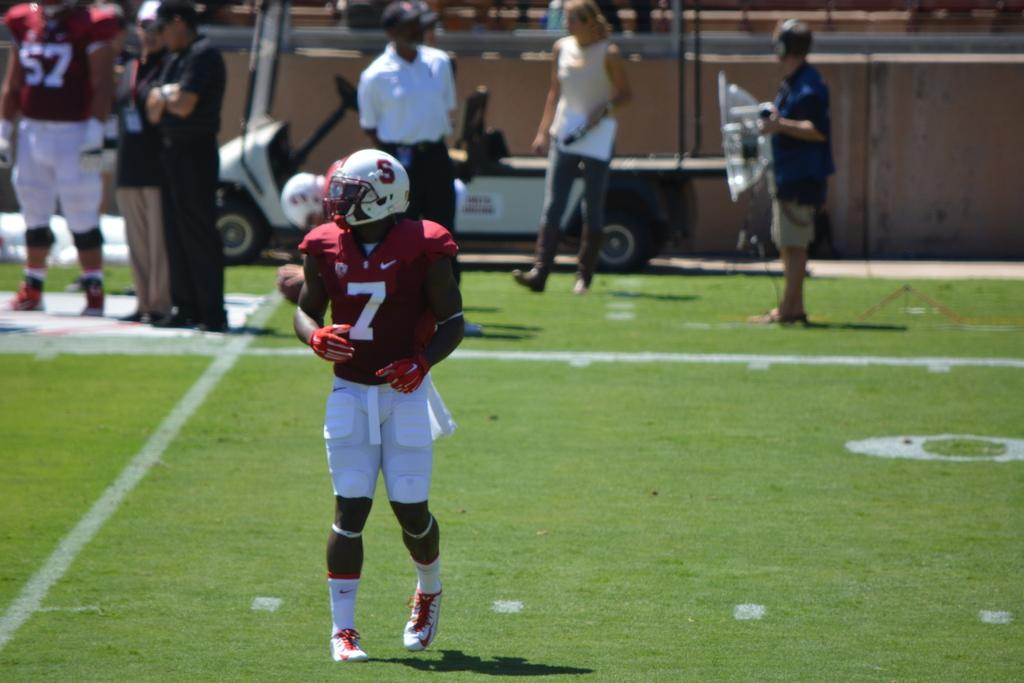What is the person in the image wearing on their head? The person in the image is wearing a helmet. What is the person's position in relation to the ground? The person is standing on the ground. What can be seen in front of the vehicle in the image? There is a group of people in front of a vehicle in the image. What is visible in the background of the image? There is a wall visible in the image. Where is the pot located in the image? There is no pot present in the image. What type of mailbox can be seen near the wall in the image? There is no mailbox present in the image. 